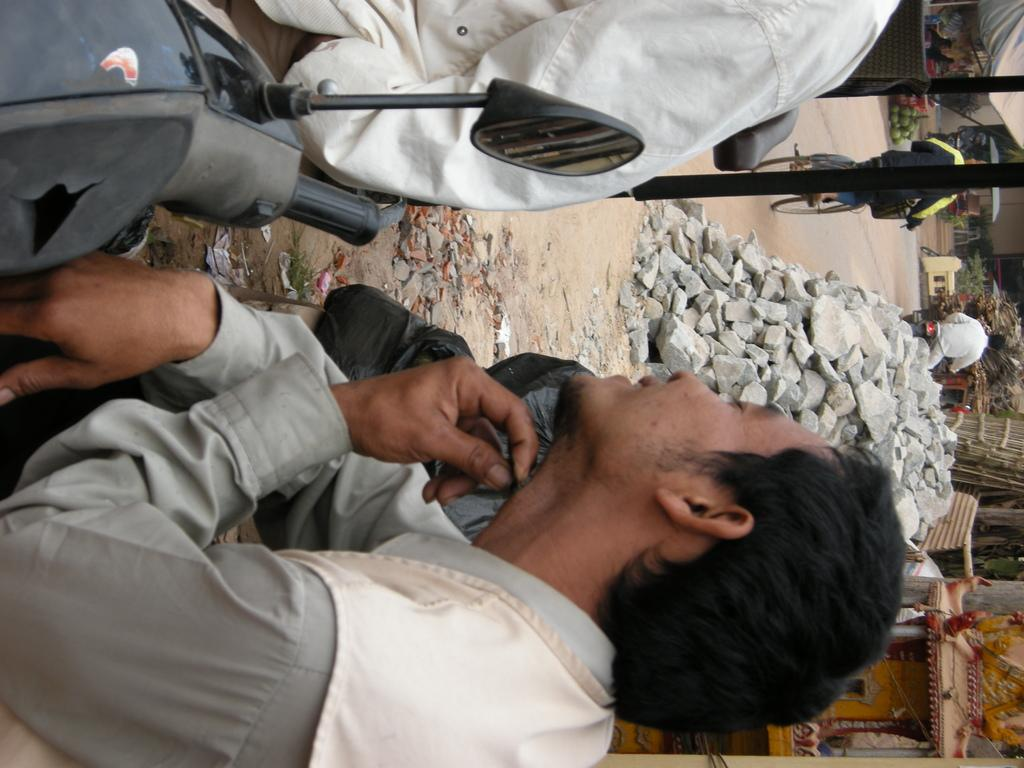What is the main subject of the image? There is a man in the image. What is the man doing in the image? The man is sitting on a bike. What can be seen in the background of the image? There are rocks in the background of the image. What is at the bottom of the image? There is a road at the bottom of the image. Can you describe the man's activity in the middle of the image? There is a man riding a bicycle in the middle of the image. What type of mask is the man wearing in the image? There is no mask present in the image. Can you tell me how many cannons are visible in the image? There are no cannons present in the image. 